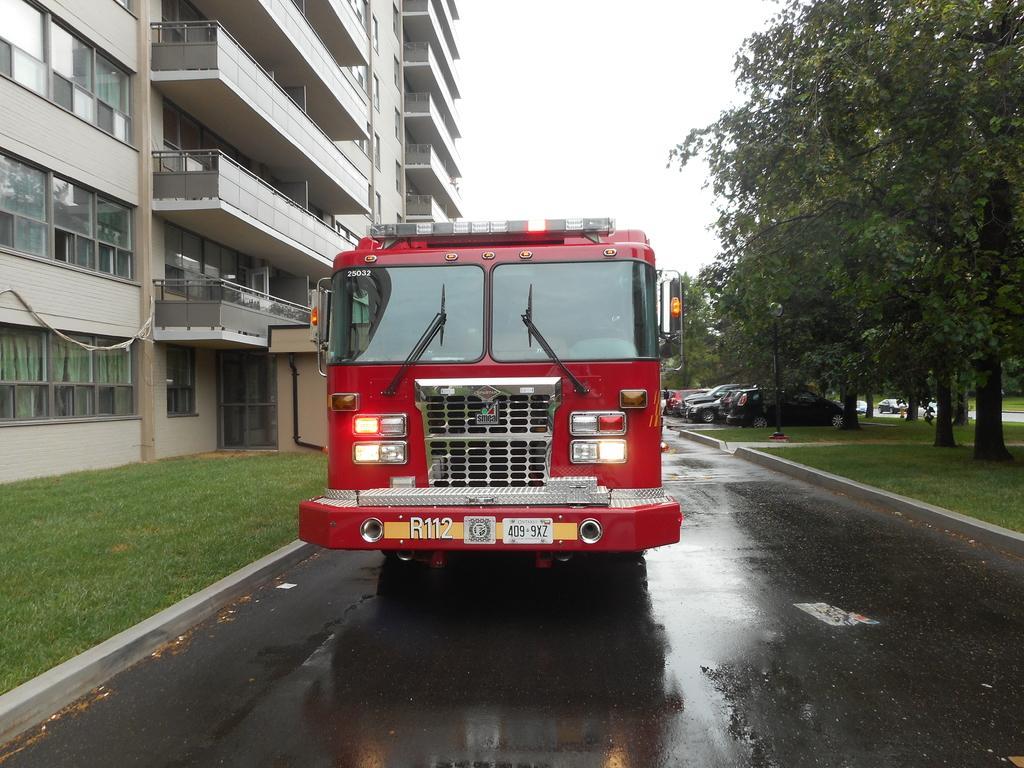Describe this image in one or two sentences. Vehicles are on the road. Beside these vehicles there are trees, grass and building. These are glass windows. 